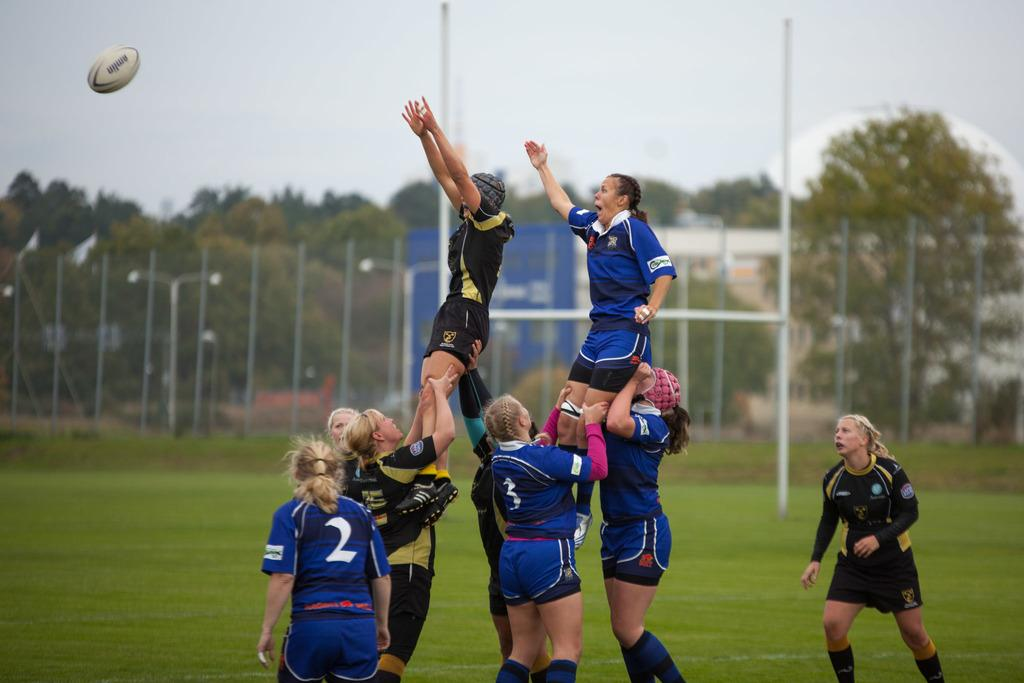<image>
Render a clear and concise summary of the photo. A girls rugby team forming a pyrimid with 3 on the bottom. 